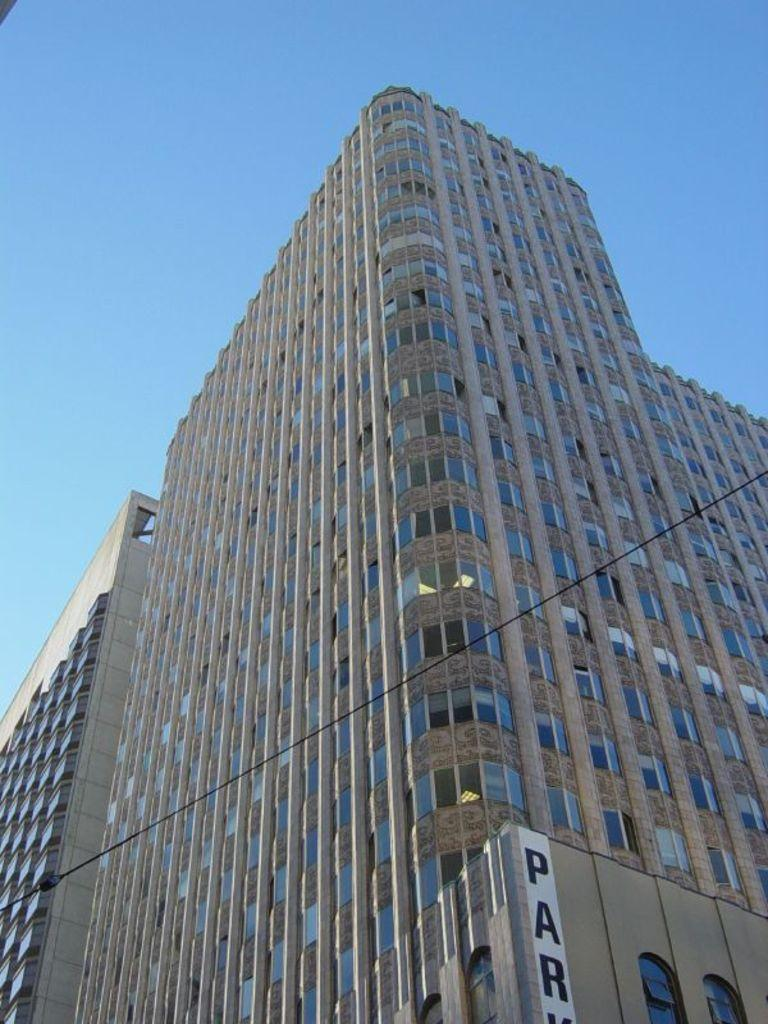What type of structures are depicted in the image? There are huge buildings in the image. What feature can be seen on the buildings? The buildings have windows. What is the condition of the sky in the image? The sky is clear in the image. Can you tell me how many noses are visible on the buildings in the image? There are no noses present on the buildings in the image; they are inanimate structures. 